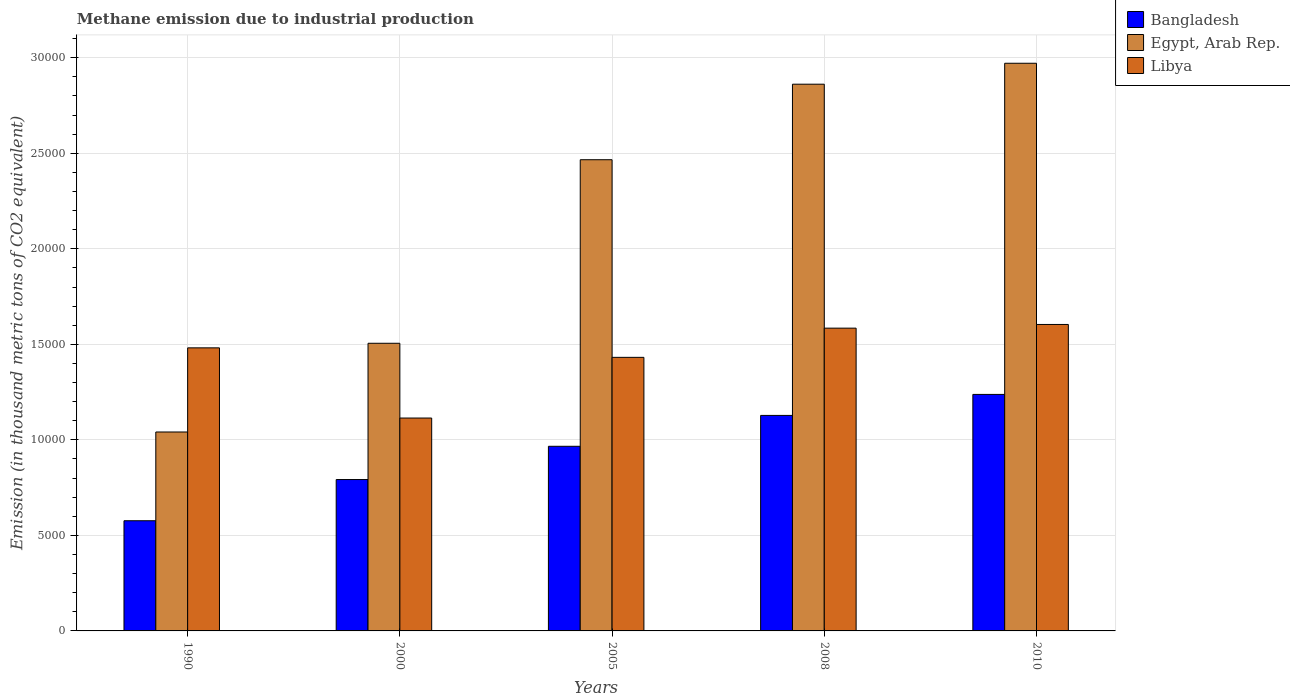How many different coloured bars are there?
Offer a very short reply. 3. Are the number of bars per tick equal to the number of legend labels?
Provide a short and direct response. Yes. Are the number of bars on each tick of the X-axis equal?
Make the answer very short. Yes. How many bars are there on the 5th tick from the right?
Provide a short and direct response. 3. What is the label of the 2nd group of bars from the left?
Keep it short and to the point. 2000. What is the amount of methane emitted in Egypt, Arab Rep. in 2010?
Make the answer very short. 2.97e+04. Across all years, what is the maximum amount of methane emitted in Libya?
Offer a terse response. 1.60e+04. Across all years, what is the minimum amount of methane emitted in Egypt, Arab Rep.?
Keep it short and to the point. 1.04e+04. In which year was the amount of methane emitted in Libya maximum?
Keep it short and to the point. 2010. What is the total amount of methane emitted in Egypt, Arab Rep. in the graph?
Your answer should be compact. 1.08e+05. What is the difference between the amount of methane emitted in Libya in 2000 and that in 2005?
Keep it short and to the point. -3176.6. What is the difference between the amount of methane emitted in Libya in 2008 and the amount of methane emitted in Egypt, Arab Rep. in 2010?
Offer a terse response. -1.39e+04. What is the average amount of methane emitted in Egypt, Arab Rep. per year?
Offer a very short reply. 2.17e+04. In the year 1990, what is the difference between the amount of methane emitted in Egypt, Arab Rep. and amount of methane emitted in Bangladesh?
Offer a terse response. 4645.7. In how many years, is the amount of methane emitted in Libya greater than 22000 thousand metric tons?
Offer a very short reply. 0. What is the ratio of the amount of methane emitted in Egypt, Arab Rep. in 1990 to that in 2010?
Give a very brief answer. 0.35. Is the difference between the amount of methane emitted in Egypt, Arab Rep. in 2008 and 2010 greater than the difference between the amount of methane emitted in Bangladesh in 2008 and 2010?
Ensure brevity in your answer.  Yes. What is the difference between the highest and the second highest amount of methane emitted in Egypt, Arab Rep.?
Your answer should be compact. 1095.6. What is the difference between the highest and the lowest amount of methane emitted in Bangladesh?
Your response must be concise. 6612.5. In how many years, is the amount of methane emitted in Libya greater than the average amount of methane emitted in Libya taken over all years?
Provide a short and direct response. 3. What does the 1st bar from the right in 2005 represents?
Your answer should be very brief. Libya. Is it the case that in every year, the sum of the amount of methane emitted in Libya and amount of methane emitted in Egypt, Arab Rep. is greater than the amount of methane emitted in Bangladesh?
Your answer should be very brief. Yes. How many bars are there?
Provide a short and direct response. 15. What is the difference between two consecutive major ticks on the Y-axis?
Provide a succinct answer. 5000. Does the graph contain any zero values?
Provide a short and direct response. No. Does the graph contain grids?
Make the answer very short. Yes. Where does the legend appear in the graph?
Ensure brevity in your answer.  Top right. How many legend labels are there?
Keep it short and to the point. 3. How are the legend labels stacked?
Provide a succinct answer. Vertical. What is the title of the graph?
Your response must be concise. Methane emission due to industrial production. What is the label or title of the Y-axis?
Your response must be concise. Emission (in thousand metric tons of CO2 equivalent). What is the Emission (in thousand metric tons of CO2 equivalent) in Bangladesh in 1990?
Provide a succinct answer. 5766.3. What is the Emission (in thousand metric tons of CO2 equivalent) of Egypt, Arab Rep. in 1990?
Provide a short and direct response. 1.04e+04. What is the Emission (in thousand metric tons of CO2 equivalent) of Libya in 1990?
Your response must be concise. 1.48e+04. What is the Emission (in thousand metric tons of CO2 equivalent) in Bangladesh in 2000?
Keep it short and to the point. 7923.4. What is the Emission (in thousand metric tons of CO2 equivalent) of Egypt, Arab Rep. in 2000?
Offer a very short reply. 1.51e+04. What is the Emission (in thousand metric tons of CO2 equivalent) in Libya in 2000?
Your answer should be compact. 1.11e+04. What is the Emission (in thousand metric tons of CO2 equivalent) of Bangladesh in 2005?
Ensure brevity in your answer.  9663.6. What is the Emission (in thousand metric tons of CO2 equivalent) of Egypt, Arab Rep. in 2005?
Your response must be concise. 2.47e+04. What is the Emission (in thousand metric tons of CO2 equivalent) of Libya in 2005?
Make the answer very short. 1.43e+04. What is the Emission (in thousand metric tons of CO2 equivalent) in Bangladesh in 2008?
Give a very brief answer. 1.13e+04. What is the Emission (in thousand metric tons of CO2 equivalent) of Egypt, Arab Rep. in 2008?
Offer a terse response. 2.86e+04. What is the Emission (in thousand metric tons of CO2 equivalent) in Libya in 2008?
Offer a very short reply. 1.58e+04. What is the Emission (in thousand metric tons of CO2 equivalent) in Bangladesh in 2010?
Your answer should be very brief. 1.24e+04. What is the Emission (in thousand metric tons of CO2 equivalent) in Egypt, Arab Rep. in 2010?
Provide a short and direct response. 2.97e+04. What is the Emission (in thousand metric tons of CO2 equivalent) in Libya in 2010?
Offer a terse response. 1.60e+04. Across all years, what is the maximum Emission (in thousand metric tons of CO2 equivalent) of Bangladesh?
Offer a terse response. 1.24e+04. Across all years, what is the maximum Emission (in thousand metric tons of CO2 equivalent) in Egypt, Arab Rep.?
Offer a terse response. 2.97e+04. Across all years, what is the maximum Emission (in thousand metric tons of CO2 equivalent) in Libya?
Your answer should be very brief. 1.60e+04. Across all years, what is the minimum Emission (in thousand metric tons of CO2 equivalent) in Bangladesh?
Your answer should be very brief. 5766.3. Across all years, what is the minimum Emission (in thousand metric tons of CO2 equivalent) of Egypt, Arab Rep.?
Ensure brevity in your answer.  1.04e+04. Across all years, what is the minimum Emission (in thousand metric tons of CO2 equivalent) in Libya?
Provide a short and direct response. 1.11e+04. What is the total Emission (in thousand metric tons of CO2 equivalent) of Bangladesh in the graph?
Make the answer very short. 4.70e+04. What is the total Emission (in thousand metric tons of CO2 equivalent) of Egypt, Arab Rep. in the graph?
Offer a very short reply. 1.08e+05. What is the total Emission (in thousand metric tons of CO2 equivalent) in Libya in the graph?
Give a very brief answer. 7.22e+04. What is the difference between the Emission (in thousand metric tons of CO2 equivalent) of Bangladesh in 1990 and that in 2000?
Offer a terse response. -2157.1. What is the difference between the Emission (in thousand metric tons of CO2 equivalent) in Egypt, Arab Rep. in 1990 and that in 2000?
Keep it short and to the point. -4642.9. What is the difference between the Emission (in thousand metric tons of CO2 equivalent) in Libya in 1990 and that in 2000?
Give a very brief answer. 3673.7. What is the difference between the Emission (in thousand metric tons of CO2 equivalent) of Bangladesh in 1990 and that in 2005?
Your answer should be very brief. -3897.3. What is the difference between the Emission (in thousand metric tons of CO2 equivalent) in Egypt, Arab Rep. in 1990 and that in 2005?
Give a very brief answer. -1.42e+04. What is the difference between the Emission (in thousand metric tons of CO2 equivalent) in Libya in 1990 and that in 2005?
Make the answer very short. 497.1. What is the difference between the Emission (in thousand metric tons of CO2 equivalent) in Bangladesh in 1990 and that in 2008?
Ensure brevity in your answer.  -5512.9. What is the difference between the Emission (in thousand metric tons of CO2 equivalent) of Egypt, Arab Rep. in 1990 and that in 2008?
Ensure brevity in your answer.  -1.82e+04. What is the difference between the Emission (in thousand metric tons of CO2 equivalent) of Libya in 1990 and that in 2008?
Provide a succinct answer. -1030.8. What is the difference between the Emission (in thousand metric tons of CO2 equivalent) in Bangladesh in 1990 and that in 2010?
Give a very brief answer. -6612.5. What is the difference between the Emission (in thousand metric tons of CO2 equivalent) of Egypt, Arab Rep. in 1990 and that in 2010?
Keep it short and to the point. -1.93e+04. What is the difference between the Emission (in thousand metric tons of CO2 equivalent) of Libya in 1990 and that in 2010?
Keep it short and to the point. -1224.2. What is the difference between the Emission (in thousand metric tons of CO2 equivalent) in Bangladesh in 2000 and that in 2005?
Give a very brief answer. -1740.2. What is the difference between the Emission (in thousand metric tons of CO2 equivalent) of Egypt, Arab Rep. in 2000 and that in 2005?
Your response must be concise. -9607. What is the difference between the Emission (in thousand metric tons of CO2 equivalent) of Libya in 2000 and that in 2005?
Your answer should be compact. -3176.6. What is the difference between the Emission (in thousand metric tons of CO2 equivalent) of Bangladesh in 2000 and that in 2008?
Your answer should be compact. -3355.8. What is the difference between the Emission (in thousand metric tons of CO2 equivalent) of Egypt, Arab Rep. in 2000 and that in 2008?
Your response must be concise. -1.36e+04. What is the difference between the Emission (in thousand metric tons of CO2 equivalent) in Libya in 2000 and that in 2008?
Offer a terse response. -4704.5. What is the difference between the Emission (in thousand metric tons of CO2 equivalent) in Bangladesh in 2000 and that in 2010?
Provide a short and direct response. -4455.4. What is the difference between the Emission (in thousand metric tons of CO2 equivalent) of Egypt, Arab Rep. in 2000 and that in 2010?
Your response must be concise. -1.47e+04. What is the difference between the Emission (in thousand metric tons of CO2 equivalent) in Libya in 2000 and that in 2010?
Provide a short and direct response. -4897.9. What is the difference between the Emission (in thousand metric tons of CO2 equivalent) in Bangladesh in 2005 and that in 2008?
Offer a very short reply. -1615.6. What is the difference between the Emission (in thousand metric tons of CO2 equivalent) in Egypt, Arab Rep. in 2005 and that in 2008?
Your answer should be very brief. -3953.4. What is the difference between the Emission (in thousand metric tons of CO2 equivalent) in Libya in 2005 and that in 2008?
Provide a succinct answer. -1527.9. What is the difference between the Emission (in thousand metric tons of CO2 equivalent) of Bangladesh in 2005 and that in 2010?
Ensure brevity in your answer.  -2715.2. What is the difference between the Emission (in thousand metric tons of CO2 equivalent) of Egypt, Arab Rep. in 2005 and that in 2010?
Your answer should be compact. -5049. What is the difference between the Emission (in thousand metric tons of CO2 equivalent) of Libya in 2005 and that in 2010?
Give a very brief answer. -1721.3. What is the difference between the Emission (in thousand metric tons of CO2 equivalent) in Bangladesh in 2008 and that in 2010?
Your answer should be compact. -1099.6. What is the difference between the Emission (in thousand metric tons of CO2 equivalent) in Egypt, Arab Rep. in 2008 and that in 2010?
Ensure brevity in your answer.  -1095.6. What is the difference between the Emission (in thousand metric tons of CO2 equivalent) in Libya in 2008 and that in 2010?
Ensure brevity in your answer.  -193.4. What is the difference between the Emission (in thousand metric tons of CO2 equivalent) of Bangladesh in 1990 and the Emission (in thousand metric tons of CO2 equivalent) of Egypt, Arab Rep. in 2000?
Make the answer very short. -9288.6. What is the difference between the Emission (in thousand metric tons of CO2 equivalent) of Bangladesh in 1990 and the Emission (in thousand metric tons of CO2 equivalent) of Libya in 2000?
Keep it short and to the point. -5375.7. What is the difference between the Emission (in thousand metric tons of CO2 equivalent) in Egypt, Arab Rep. in 1990 and the Emission (in thousand metric tons of CO2 equivalent) in Libya in 2000?
Offer a very short reply. -730. What is the difference between the Emission (in thousand metric tons of CO2 equivalent) in Bangladesh in 1990 and the Emission (in thousand metric tons of CO2 equivalent) in Egypt, Arab Rep. in 2005?
Keep it short and to the point. -1.89e+04. What is the difference between the Emission (in thousand metric tons of CO2 equivalent) in Bangladesh in 1990 and the Emission (in thousand metric tons of CO2 equivalent) in Libya in 2005?
Your answer should be compact. -8552.3. What is the difference between the Emission (in thousand metric tons of CO2 equivalent) in Egypt, Arab Rep. in 1990 and the Emission (in thousand metric tons of CO2 equivalent) in Libya in 2005?
Ensure brevity in your answer.  -3906.6. What is the difference between the Emission (in thousand metric tons of CO2 equivalent) of Bangladesh in 1990 and the Emission (in thousand metric tons of CO2 equivalent) of Egypt, Arab Rep. in 2008?
Make the answer very short. -2.28e+04. What is the difference between the Emission (in thousand metric tons of CO2 equivalent) of Bangladesh in 1990 and the Emission (in thousand metric tons of CO2 equivalent) of Libya in 2008?
Keep it short and to the point. -1.01e+04. What is the difference between the Emission (in thousand metric tons of CO2 equivalent) of Egypt, Arab Rep. in 1990 and the Emission (in thousand metric tons of CO2 equivalent) of Libya in 2008?
Keep it short and to the point. -5434.5. What is the difference between the Emission (in thousand metric tons of CO2 equivalent) in Bangladesh in 1990 and the Emission (in thousand metric tons of CO2 equivalent) in Egypt, Arab Rep. in 2010?
Offer a very short reply. -2.39e+04. What is the difference between the Emission (in thousand metric tons of CO2 equivalent) in Bangladesh in 1990 and the Emission (in thousand metric tons of CO2 equivalent) in Libya in 2010?
Provide a short and direct response. -1.03e+04. What is the difference between the Emission (in thousand metric tons of CO2 equivalent) of Egypt, Arab Rep. in 1990 and the Emission (in thousand metric tons of CO2 equivalent) of Libya in 2010?
Provide a short and direct response. -5627.9. What is the difference between the Emission (in thousand metric tons of CO2 equivalent) of Bangladesh in 2000 and the Emission (in thousand metric tons of CO2 equivalent) of Egypt, Arab Rep. in 2005?
Your response must be concise. -1.67e+04. What is the difference between the Emission (in thousand metric tons of CO2 equivalent) of Bangladesh in 2000 and the Emission (in thousand metric tons of CO2 equivalent) of Libya in 2005?
Offer a very short reply. -6395.2. What is the difference between the Emission (in thousand metric tons of CO2 equivalent) in Egypt, Arab Rep. in 2000 and the Emission (in thousand metric tons of CO2 equivalent) in Libya in 2005?
Your answer should be very brief. 736.3. What is the difference between the Emission (in thousand metric tons of CO2 equivalent) of Bangladesh in 2000 and the Emission (in thousand metric tons of CO2 equivalent) of Egypt, Arab Rep. in 2008?
Ensure brevity in your answer.  -2.07e+04. What is the difference between the Emission (in thousand metric tons of CO2 equivalent) in Bangladesh in 2000 and the Emission (in thousand metric tons of CO2 equivalent) in Libya in 2008?
Your answer should be very brief. -7923.1. What is the difference between the Emission (in thousand metric tons of CO2 equivalent) in Egypt, Arab Rep. in 2000 and the Emission (in thousand metric tons of CO2 equivalent) in Libya in 2008?
Your response must be concise. -791.6. What is the difference between the Emission (in thousand metric tons of CO2 equivalent) of Bangladesh in 2000 and the Emission (in thousand metric tons of CO2 equivalent) of Egypt, Arab Rep. in 2010?
Your answer should be compact. -2.18e+04. What is the difference between the Emission (in thousand metric tons of CO2 equivalent) in Bangladesh in 2000 and the Emission (in thousand metric tons of CO2 equivalent) in Libya in 2010?
Give a very brief answer. -8116.5. What is the difference between the Emission (in thousand metric tons of CO2 equivalent) of Egypt, Arab Rep. in 2000 and the Emission (in thousand metric tons of CO2 equivalent) of Libya in 2010?
Keep it short and to the point. -985. What is the difference between the Emission (in thousand metric tons of CO2 equivalent) of Bangladesh in 2005 and the Emission (in thousand metric tons of CO2 equivalent) of Egypt, Arab Rep. in 2008?
Offer a very short reply. -1.90e+04. What is the difference between the Emission (in thousand metric tons of CO2 equivalent) of Bangladesh in 2005 and the Emission (in thousand metric tons of CO2 equivalent) of Libya in 2008?
Provide a short and direct response. -6182.9. What is the difference between the Emission (in thousand metric tons of CO2 equivalent) in Egypt, Arab Rep. in 2005 and the Emission (in thousand metric tons of CO2 equivalent) in Libya in 2008?
Your answer should be compact. 8815.4. What is the difference between the Emission (in thousand metric tons of CO2 equivalent) in Bangladesh in 2005 and the Emission (in thousand metric tons of CO2 equivalent) in Egypt, Arab Rep. in 2010?
Make the answer very short. -2.00e+04. What is the difference between the Emission (in thousand metric tons of CO2 equivalent) of Bangladesh in 2005 and the Emission (in thousand metric tons of CO2 equivalent) of Libya in 2010?
Your response must be concise. -6376.3. What is the difference between the Emission (in thousand metric tons of CO2 equivalent) of Egypt, Arab Rep. in 2005 and the Emission (in thousand metric tons of CO2 equivalent) of Libya in 2010?
Keep it short and to the point. 8622. What is the difference between the Emission (in thousand metric tons of CO2 equivalent) of Bangladesh in 2008 and the Emission (in thousand metric tons of CO2 equivalent) of Egypt, Arab Rep. in 2010?
Offer a very short reply. -1.84e+04. What is the difference between the Emission (in thousand metric tons of CO2 equivalent) of Bangladesh in 2008 and the Emission (in thousand metric tons of CO2 equivalent) of Libya in 2010?
Provide a succinct answer. -4760.7. What is the difference between the Emission (in thousand metric tons of CO2 equivalent) of Egypt, Arab Rep. in 2008 and the Emission (in thousand metric tons of CO2 equivalent) of Libya in 2010?
Offer a terse response. 1.26e+04. What is the average Emission (in thousand metric tons of CO2 equivalent) in Bangladesh per year?
Offer a very short reply. 9402.26. What is the average Emission (in thousand metric tons of CO2 equivalent) in Egypt, Arab Rep. per year?
Your answer should be compact. 2.17e+04. What is the average Emission (in thousand metric tons of CO2 equivalent) of Libya per year?
Make the answer very short. 1.44e+04. In the year 1990, what is the difference between the Emission (in thousand metric tons of CO2 equivalent) in Bangladesh and Emission (in thousand metric tons of CO2 equivalent) in Egypt, Arab Rep.?
Offer a terse response. -4645.7. In the year 1990, what is the difference between the Emission (in thousand metric tons of CO2 equivalent) in Bangladesh and Emission (in thousand metric tons of CO2 equivalent) in Libya?
Provide a short and direct response. -9049.4. In the year 1990, what is the difference between the Emission (in thousand metric tons of CO2 equivalent) of Egypt, Arab Rep. and Emission (in thousand metric tons of CO2 equivalent) of Libya?
Offer a very short reply. -4403.7. In the year 2000, what is the difference between the Emission (in thousand metric tons of CO2 equivalent) of Bangladesh and Emission (in thousand metric tons of CO2 equivalent) of Egypt, Arab Rep.?
Provide a short and direct response. -7131.5. In the year 2000, what is the difference between the Emission (in thousand metric tons of CO2 equivalent) of Bangladesh and Emission (in thousand metric tons of CO2 equivalent) of Libya?
Provide a short and direct response. -3218.6. In the year 2000, what is the difference between the Emission (in thousand metric tons of CO2 equivalent) in Egypt, Arab Rep. and Emission (in thousand metric tons of CO2 equivalent) in Libya?
Offer a very short reply. 3912.9. In the year 2005, what is the difference between the Emission (in thousand metric tons of CO2 equivalent) in Bangladesh and Emission (in thousand metric tons of CO2 equivalent) in Egypt, Arab Rep.?
Offer a terse response. -1.50e+04. In the year 2005, what is the difference between the Emission (in thousand metric tons of CO2 equivalent) in Bangladesh and Emission (in thousand metric tons of CO2 equivalent) in Libya?
Offer a terse response. -4655. In the year 2005, what is the difference between the Emission (in thousand metric tons of CO2 equivalent) of Egypt, Arab Rep. and Emission (in thousand metric tons of CO2 equivalent) of Libya?
Keep it short and to the point. 1.03e+04. In the year 2008, what is the difference between the Emission (in thousand metric tons of CO2 equivalent) of Bangladesh and Emission (in thousand metric tons of CO2 equivalent) of Egypt, Arab Rep.?
Your answer should be compact. -1.73e+04. In the year 2008, what is the difference between the Emission (in thousand metric tons of CO2 equivalent) in Bangladesh and Emission (in thousand metric tons of CO2 equivalent) in Libya?
Your answer should be compact. -4567.3. In the year 2008, what is the difference between the Emission (in thousand metric tons of CO2 equivalent) in Egypt, Arab Rep. and Emission (in thousand metric tons of CO2 equivalent) in Libya?
Your answer should be very brief. 1.28e+04. In the year 2010, what is the difference between the Emission (in thousand metric tons of CO2 equivalent) of Bangladesh and Emission (in thousand metric tons of CO2 equivalent) of Egypt, Arab Rep.?
Give a very brief answer. -1.73e+04. In the year 2010, what is the difference between the Emission (in thousand metric tons of CO2 equivalent) in Bangladesh and Emission (in thousand metric tons of CO2 equivalent) in Libya?
Your answer should be compact. -3661.1. In the year 2010, what is the difference between the Emission (in thousand metric tons of CO2 equivalent) in Egypt, Arab Rep. and Emission (in thousand metric tons of CO2 equivalent) in Libya?
Your answer should be compact. 1.37e+04. What is the ratio of the Emission (in thousand metric tons of CO2 equivalent) of Bangladesh in 1990 to that in 2000?
Make the answer very short. 0.73. What is the ratio of the Emission (in thousand metric tons of CO2 equivalent) of Egypt, Arab Rep. in 1990 to that in 2000?
Provide a succinct answer. 0.69. What is the ratio of the Emission (in thousand metric tons of CO2 equivalent) of Libya in 1990 to that in 2000?
Offer a very short reply. 1.33. What is the ratio of the Emission (in thousand metric tons of CO2 equivalent) of Bangladesh in 1990 to that in 2005?
Make the answer very short. 0.6. What is the ratio of the Emission (in thousand metric tons of CO2 equivalent) in Egypt, Arab Rep. in 1990 to that in 2005?
Give a very brief answer. 0.42. What is the ratio of the Emission (in thousand metric tons of CO2 equivalent) in Libya in 1990 to that in 2005?
Your answer should be very brief. 1.03. What is the ratio of the Emission (in thousand metric tons of CO2 equivalent) of Bangladesh in 1990 to that in 2008?
Provide a short and direct response. 0.51. What is the ratio of the Emission (in thousand metric tons of CO2 equivalent) of Egypt, Arab Rep. in 1990 to that in 2008?
Make the answer very short. 0.36. What is the ratio of the Emission (in thousand metric tons of CO2 equivalent) of Libya in 1990 to that in 2008?
Your answer should be very brief. 0.94. What is the ratio of the Emission (in thousand metric tons of CO2 equivalent) of Bangladesh in 1990 to that in 2010?
Provide a short and direct response. 0.47. What is the ratio of the Emission (in thousand metric tons of CO2 equivalent) in Egypt, Arab Rep. in 1990 to that in 2010?
Provide a succinct answer. 0.35. What is the ratio of the Emission (in thousand metric tons of CO2 equivalent) of Libya in 1990 to that in 2010?
Keep it short and to the point. 0.92. What is the ratio of the Emission (in thousand metric tons of CO2 equivalent) in Bangladesh in 2000 to that in 2005?
Offer a very short reply. 0.82. What is the ratio of the Emission (in thousand metric tons of CO2 equivalent) in Egypt, Arab Rep. in 2000 to that in 2005?
Offer a very short reply. 0.61. What is the ratio of the Emission (in thousand metric tons of CO2 equivalent) in Libya in 2000 to that in 2005?
Offer a very short reply. 0.78. What is the ratio of the Emission (in thousand metric tons of CO2 equivalent) in Bangladesh in 2000 to that in 2008?
Keep it short and to the point. 0.7. What is the ratio of the Emission (in thousand metric tons of CO2 equivalent) of Egypt, Arab Rep. in 2000 to that in 2008?
Offer a terse response. 0.53. What is the ratio of the Emission (in thousand metric tons of CO2 equivalent) of Libya in 2000 to that in 2008?
Provide a succinct answer. 0.7. What is the ratio of the Emission (in thousand metric tons of CO2 equivalent) of Bangladesh in 2000 to that in 2010?
Your response must be concise. 0.64. What is the ratio of the Emission (in thousand metric tons of CO2 equivalent) of Egypt, Arab Rep. in 2000 to that in 2010?
Give a very brief answer. 0.51. What is the ratio of the Emission (in thousand metric tons of CO2 equivalent) of Libya in 2000 to that in 2010?
Your answer should be compact. 0.69. What is the ratio of the Emission (in thousand metric tons of CO2 equivalent) in Bangladesh in 2005 to that in 2008?
Keep it short and to the point. 0.86. What is the ratio of the Emission (in thousand metric tons of CO2 equivalent) in Egypt, Arab Rep. in 2005 to that in 2008?
Keep it short and to the point. 0.86. What is the ratio of the Emission (in thousand metric tons of CO2 equivalent) in Libya in 2005 to that in 2008?
Offer a very short reply. 0.9. What is the ratio of the Emission (in thousand metric tons of CO2 equivalent) of Bangladesh in 2005 to that in 2010?
Provide a short and direct response. 0.78. What is the ratio of the Emission (in thousand metric tons of CO2 equivalent) in Egypt, Arab Rep. in 2005 to that in 2010?
Offer a terse response. 0.83. What is the ratio of the Emission (in thousand metric tons of CO2 equivalent) in Libya in 2005 to that in 2010?
Make the answer very short. 0.89. What is the ratio of the Emission (in thousand metric tons of CO2 equivalent) of Bangladesh in 2008 to that in 2010?
Make the answer very short. 0.91. What is the ratio of the Emission (in thousand metric tons of CO2 equivalent) in Egypt, Arab Rep. in 2008 to that in 2010?
Keep it short and to the point. 0.96. What is the ratio of the Emission (in thousand metric tons of CO2 equivalent) of Libya in 2008 to that in 2010?
Provide a succinct answer. 0.99. What is the difference between the highest and the second highest Emission (in thousand metric tons of CO2 equivalent) of Bangladesh?
Ensure brevity in your answer.  1099.6. What is the difference between the highest and the second highest Emission (in thousand metric tons of CO2 equivalent) of Egypt, Arab Rep.?
Provide a short and direct response. 1095.6. What is the difference between the highest and the second highest Emission (in thousand metric tons of CO2 equivalent) of Libya?
Make the answer very short. 193.4. What is the difference between the highest and the lowest Emission (in thousand metric tons of CO2 equivalent) of Bangladesh?
Provide a succinct answer. 6612.5. What is the difference between the highest and the lowest Emission (in thousand metric tons of CO2 equivalent) of Egypt, Arab Rep.?
Ensure brevity in your answer.  1.93e+04. What is the difference between the highest and the lowest Emission (in thousand metric tons of CO2 equivalent) of Libya?
Give a very brief answer. 4897.9. 